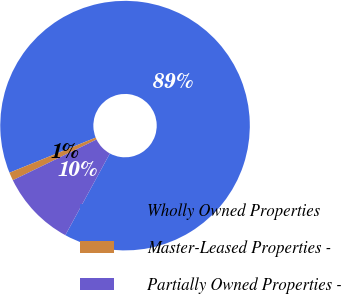<chart> <loc_0><loc_0><loc_500><loc_500><pie_chart><fcel>Wholly Owned Properties<fcel>Master-Leased Properties -<fcel>Partially Owned Properties -<nl><fcel>89.1%<fcel>1.05%<fcel>9.85%<nl></chart> 